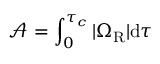<formula> <loc_0><loc_0><loc_500><loc_500>\mathcal { A } = \int _ { 0 } ^ { \tau _ { c } } | \Omega _ { R } | d \tau</formula> 